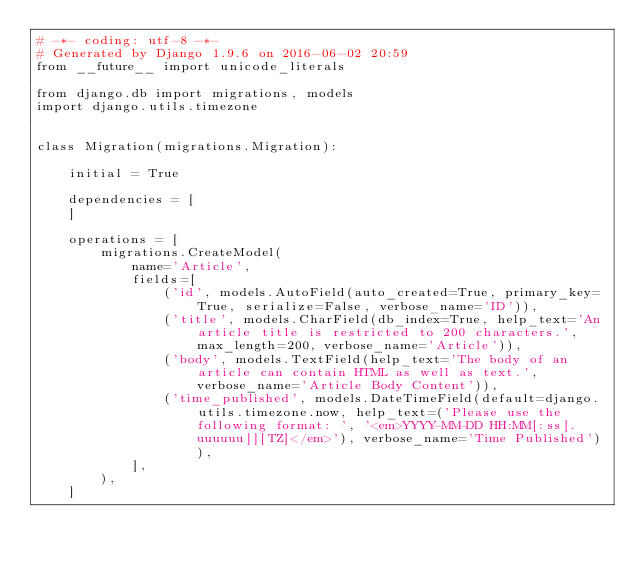Convert code to text. <code><loc_0><loc_0><loc_500><loc_500><_Python_># -*- coding: utf-8 -*-
# Generated by Django 1.9.6 on 2016-06-02 20:59
from __future__ import unicode_literals

from django.db import migrations, models
import django.utils.timezone


class Migration(migrations.Migration):

    initial = True

    dependencies = [
    ]

    operations = [
        migrations.CreateModel(
            name='Article',
            fields=[
                ('id', models.AutoField(auto_created=True, primary_key=True, serialize=False, verbose_name='ID')),
                ('title', models.CharField(db_index=True, help_text='An article title is restricted to 200 characters.', max_length=200, verbose_name='Article')),
                ('body', models.TextField(help_text='The body of an article can contain HTML as well as text.', verbose_name='Article Body Content')),
                ('time_published', models.DateTimeField(default=django.utils.timezone.now, help_text=('Please use the following format: ', '<em>YYYY-MM-DD HH:MM[:ss[.uuuuuu]][TZ]</em>'), verbose_name='Time Published')),
            ],
        ),
    ]
</code> 